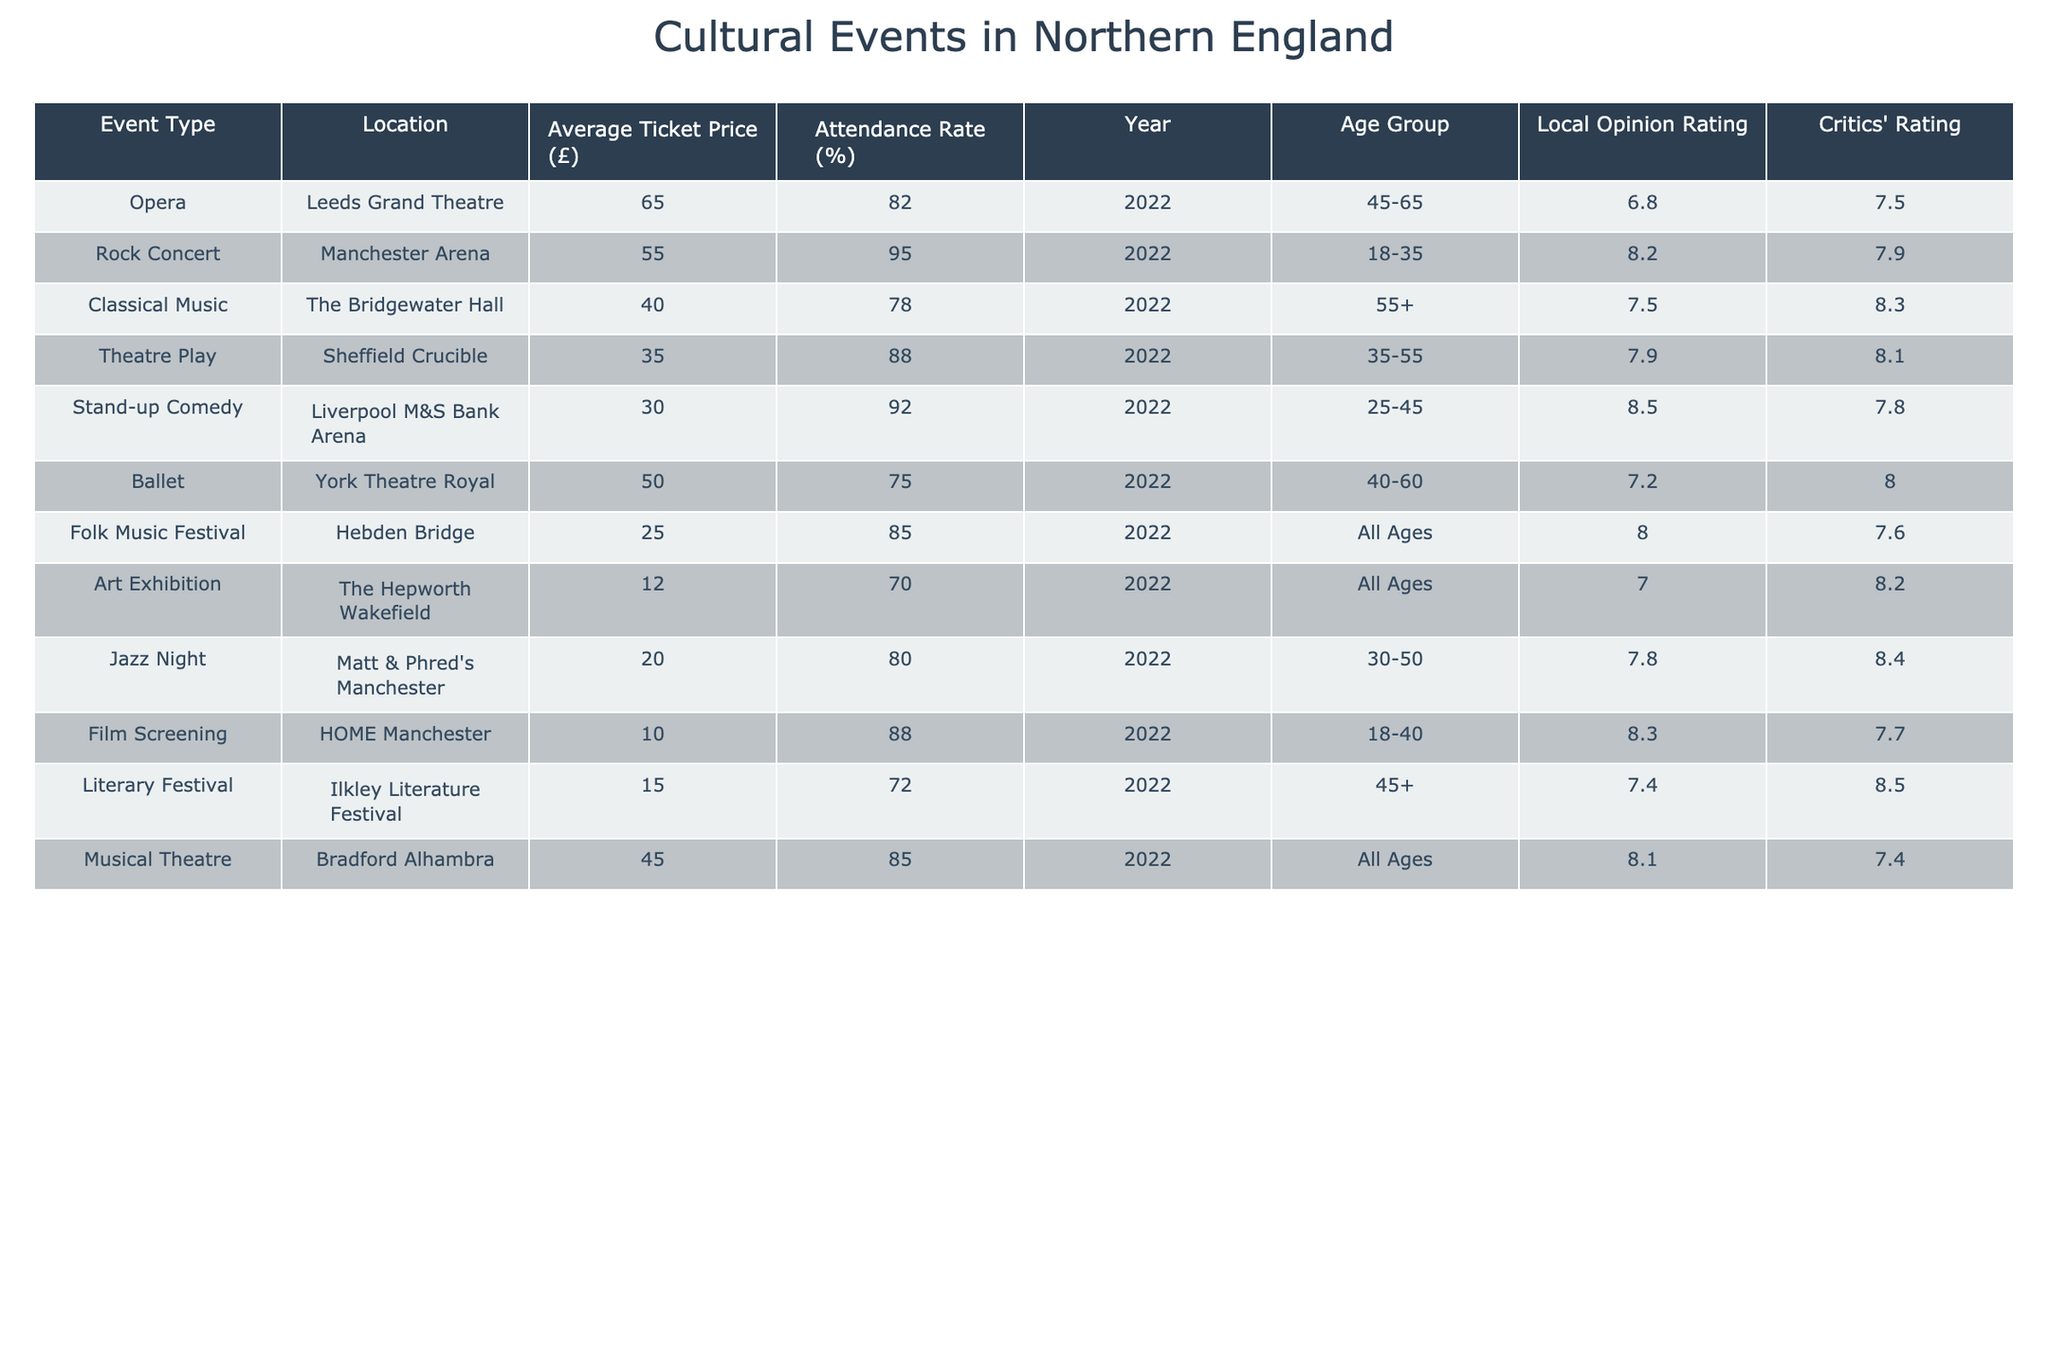What is the average ticket price for all events? To find the average ticket price, we need to sum all the average ticket prices and divide by the number of events. The prices are: 65, 55, 40, 35, 30, 50, 25, 12, 20, 10, 15, 45. The total is 65 + 55 + 40 + 35 + 30 + 50 + 25 + 12 + 20 + 10 + 15 + 45 =  392. There are 12 events, so the average ticket price is 392 / 12 = 32.67
Answer: £32.67 Which event has the highest attendance rate? Looking through the attendance rates in the table, the highest rate is 95% for the Rock Concert at Manchester Arena.
Answer: Rock Concert Is the average ticket price for stand-up comedy less than £40? The average ticket price for stand-up comedy is £30, which is less than £40. Therefore, the statement is true.
Answer: Yes Compute the difference in attendance rate between the highest and lowest rates. The highest attendance rate is 95% (Rock Concert) and the lowest is 70% (Art Exhibition). The difference is 95% - 70% = 25%.
Answer: 25% What is the average local opinion rating for events targeted at the 45+ age group? The local opinion ratings for events aimed at the 45+ age group are 6.8 (Opera), 7.4 (Literary Festival), and 8.1 (Musical Theatre). Thus, to find the average, we sum these ratings: 6.8 + 7.4 + 8.1 = 22.3. There are 3 events, so the average rating is 22.3 / 3 = 7.43.
Answer: 7.43 Is there a positive correlation between ticket price and attendance rates? Observing the ticket prices and attendance rates, there isn't a clear positive correlation. For example, the highest ticket price (£65) has an attendance rate of 82%, whereas a lower price (£25) has an attendance rate of 85%. This suggests that higher prices do not directly result in higher attendance.
Answer: No What is the total attendance rate for events in Bradford and Sheffield combined? The attendance rates for the events in Bradford (Musical Theatre, 85%) and Sheffield (Theatre Play, 88%) are summed to find the total: 85% + 88% = 173%.
Answer: 173% Which location hosts the lowest-priced event? The lowest-priced event is the Art Exhibition at The Hepworth Wakefield, which has an average ticket price of £12.
Answer: The Hepworth Wakefield What is the critics' rating for the event with the highest local opinion rating? The event with the highest local opinion rating is Stand-up Comedy with a rating of 8.5. Looking at the table, its critics' rating is 7.8.
Answer: 7.8 